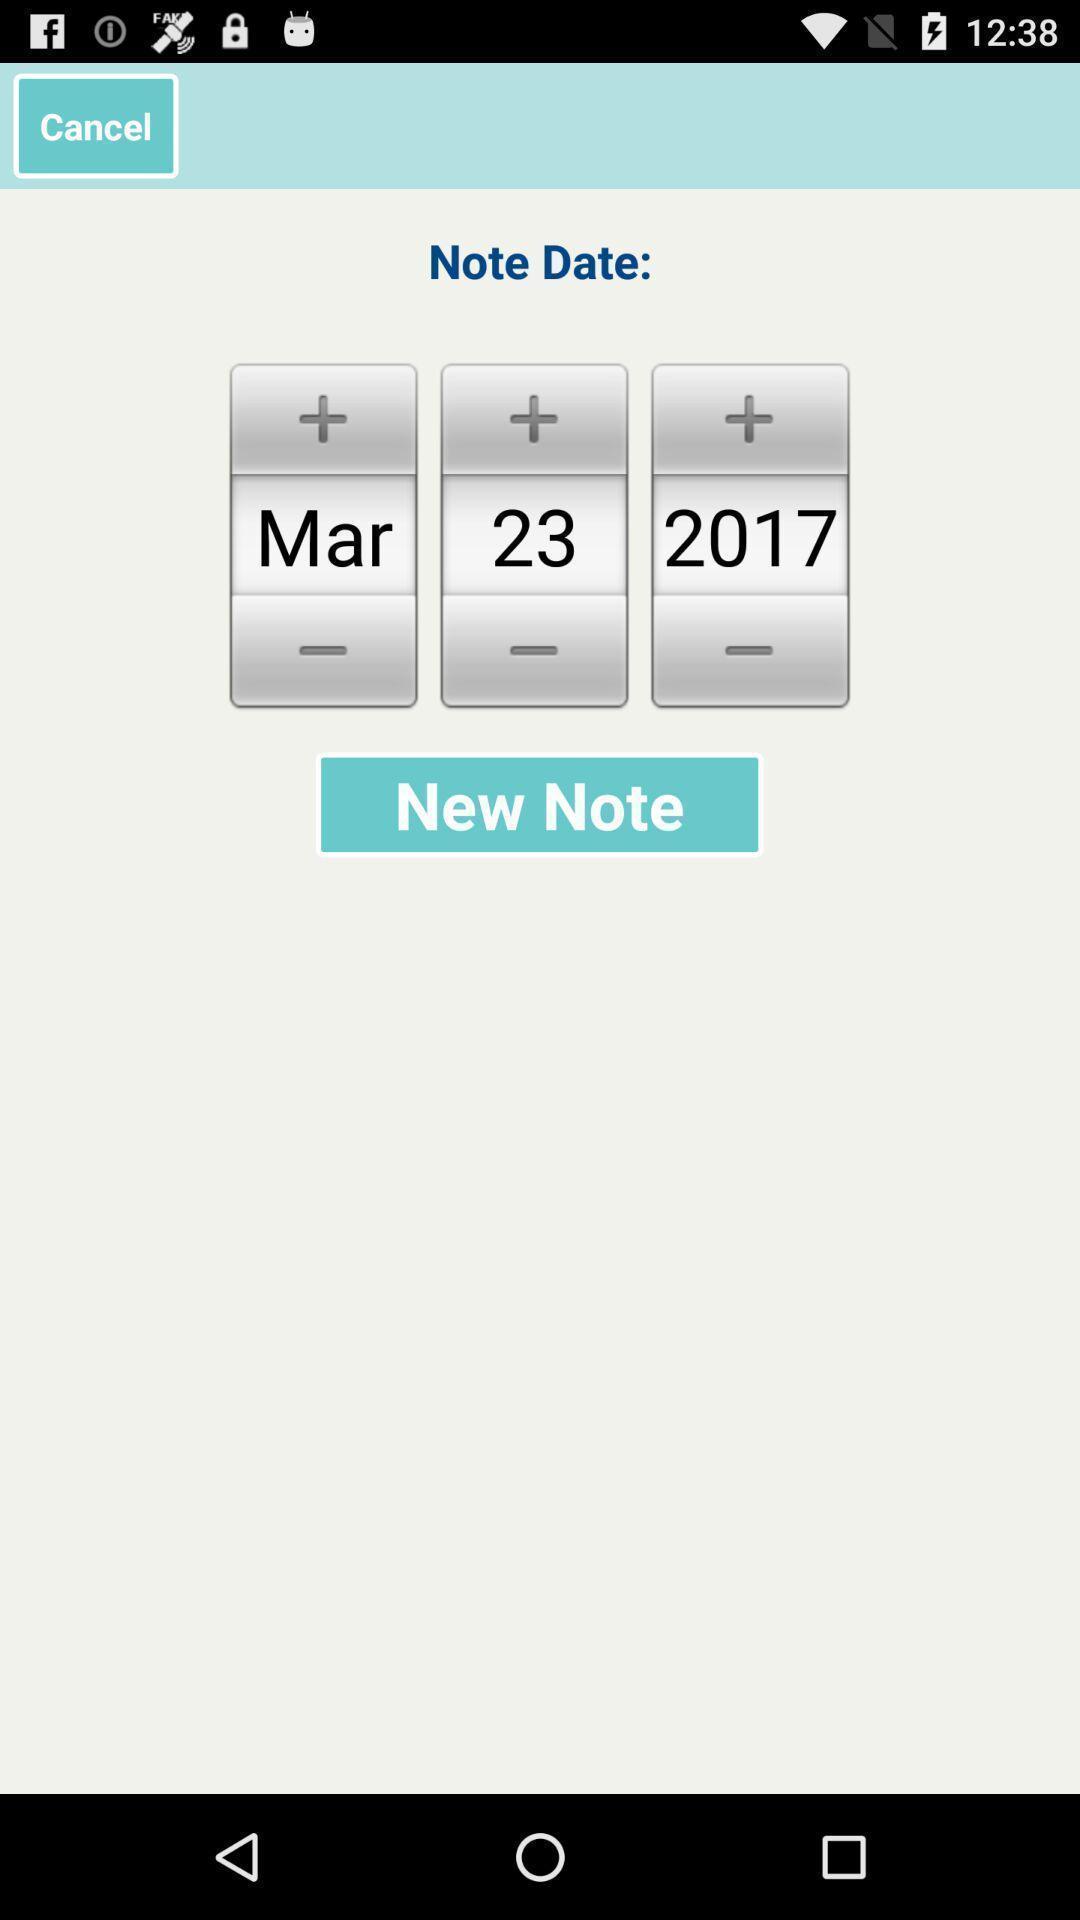Provide a description of this screenshot. Page to select date. 